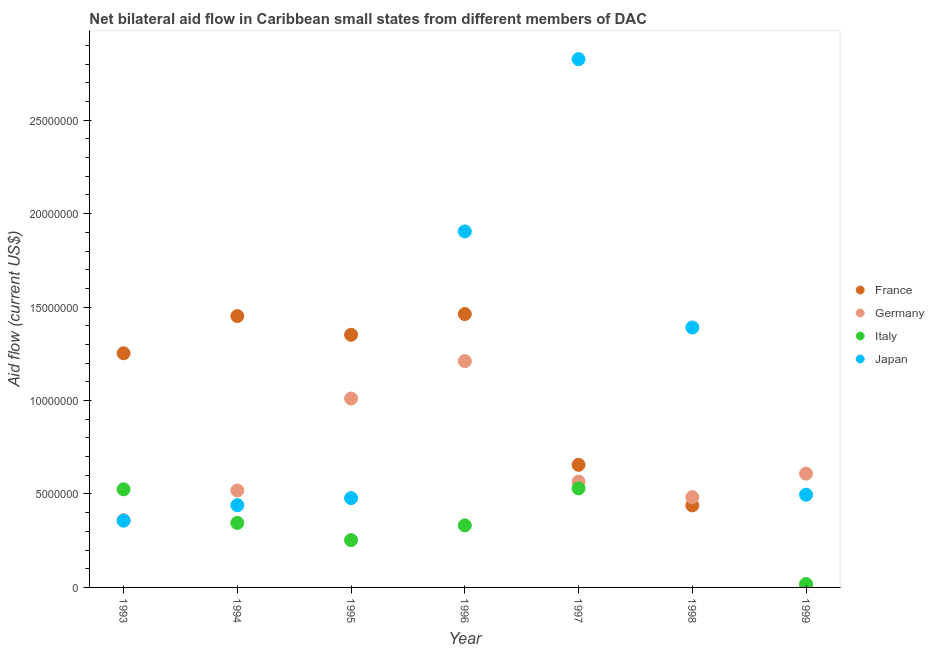What is the amount of aid given by italy in 1997?
Give a very brief answer. 5.30e+06. Across all years, what is the maximum amount of aid given by france?
Keep it short and to the point. 1.46e+07. Across all years, what is the minimum amount of aid given by france?
Offer a terse response. 10000. In which year was the amount of aid given by japan maximum?
Make the answer very short. 1997. What is the total amount of aid given by italy in the graph?
Keep it short and to the point. 2.00e+07. What is the difference between the amount of aid given by japan in 1998 and that in 1999?
Your answer should be compact. 8.95e+06. What is the difference between the amount of aid given by italy in 1993 and the amount of aid given by germany in 1995?
Make the answer very short. -4.86e+06. What is the average amount of aid given by italy per year?
Your answer should be very brief. 2.86e+06. In the year 1994, what is the difference between the amount of aid given by japan and amount of aid given by italy?
Offer a terse response. 9.50e+05. In how many years, is the amount of aid given by japan greater than 28000000 US$?
Offer a terse response. 1. What is the ratio of the amount of aid given by germany in 1994 to that in 1996?
Ensure brevity in your answer.  0.43. What is the difference between the highest and the second highest amount of aid given by france?
Your answer should be compact. 1.10e+05. What is the difference between the highest and the lowest amount of aid given by france?
Give a very brief answer. 1.46e+07. In how many years, is the amount of aid given by france greater than the average amount of aid given by france taken over all years?
Your answer should be very brief. 4. Is the sum of the amount of aid given by italy in 1993 and 1996 greater than the maximum amount of aid given by japan across all years?
Provide a short and direct response. No. Is it the case that in every year, the sum of the amount of aid given by france and amount of aid given by germany is greater than the amount of aid given by italy?
Offer a terse response. Yes. What is the difference between two consecutive major ticks on the Y-axis?
Offer a very short reply. 5.00e+06. Are the values on the major ticks of Y-axis written in scientific E-notation?
Offer a terse response. No. What is the title of the graph?
Offer a very short reply. Net bilateral aid flow in Caribbean small states from different members of DAC. What is the label or title of the Y-axis?
Give a very brief answer. Aid flow (current US$). What is the Aid flow (current US$) of France in 1993?
Your answer should be very brief. 1.25e+07. What is the Aid flow (current US$) in Germany in 1993?
Your answer should be compact. 3.60e+06. What is the Aid flow (current US$) of Italy in 1993?
Ensure brevity in your answer.  5.25e+06. What is the Aid flow (current US$) in Japan in 1993?
Ensure brevity in your answer.  3.57e+06. What is the Aid flow (current US$) of France in 1994?
Provide a short and direct response. 1.45e+07. What is the Aid flow (current US$) in Germany in 1994?
Offer a very short reply. 5.19e+06. What is the Aid flow (current US$) in Italy in 1994?
Make the answer very short. 3.45e+06. What is the Aid flow (current US$) of Japan in 1994?
Make the answer very short. 4.40e+06. What is the Aid flow (current US$) in France in 1995?
Your answer should be very brief. 1.35e+07. What is the Aid flow (current US$) in Germany in 1995?
Give a very brief answer. 1.01e+07. What is the Aid flow (current US$) of Italy in 1995?
Ensure brevity in your answer.  2.53e+06. What is the Aid flow (current US$) in Japan in 1995?
Offer a very short reply. 4.78e+06. What is the Aid flow (current US$) of France in 1996?
Offer a very short reply. 1.46e+07. What is the Aid flow (current US$) of Germany in 1996?
Make the answer very short. 1.21e+07. What is the Aid flow (current US$) of Italy in 1996?
Ensure brevity in your answer.  3.32e+06. What is the Aid flow (current US$) of Japan in 1996?
Ensure brevity in your answer.  1.90e+07. What is the Aid flow (current US$) of France in 1997?
Keep it short and to the point. 6.56e+06. What is the Aid flow (current US$) in Germany in 1997?
Your answer should be compact. 5.66e+06. What is the Aid flow (current US$) of Italy in 1997?
Your answer should be very brief. 5.30e+06. What is the Aid flow (current US$) of Japan in 1997?
Provide a succinct answer. 2.83e+07. What is the Aid flow (current US$) in France in 1998?
Provide a short and direct response. 4.39e+06. What is the Aid flow (current US$) in Germany in 1998?
Provide a short and direct response. 4.83e+06. What is the Aid flow (current US$) of Japan in 1998?
Your answer should be very brief. 1.39e+07. What is the Aid flow (current US$) in France in 1999?
Provide a short and direct response. 10000. What is the Aid flow (current US$) in Germany in 1999?
Give a very brief answer. 6.09e+06. What is the Aid flow (current US$) of Japan in 1999?
Give a very brief answer. 4.96e+06. Across all years, what is the maximum Aid flow (current US$) in France?
Offer a very short reply. 1.46e+07. Across all years, what is the maximum Aid flow (current US$) of Germany?
Your answer should be very brief. 1.21e+07. Across all years, what is the maximum Aid flow (current US$) of Italy?
Offer a terse response. 5.30e+06. Across all years, what is the maximum Aid flow (current US$) in Japan?
Provide a short and direct response. 2.83e+07. Across all years, what is the minimum Aid flow (current US$) of France?
Offer a very short reply. 10000. Across all years, what is the minimum Aid flow (current US$) of Germany?
Give a very brief answer. 3.60e+06. Across all years, what is the minimum Aid flow (current US$) of Italy?
Offer a very short reply. 0. Across all years, what is the minimum Aid flow (current US$) of Japan?
Make the answer very short. 3.57e+06. What is the total Aid flow (current US$) in France in the graph?
Your answer should be compact. 6.62e+07. What is the total Aid flow (current US$) in Germany in the graph?
Provide a short and direct response. 4.76e+07. What is the total Aid flow (current US$) in Italy in the graph?
Ensure brevity in your answer.  2.00e+07. What is the total Aid flow (current US$) of Japan in the graph?
Give a very brief answer. 7.89e+07. What is the difference between the Aid flow (current US$) in France in 1993 and that in 1994?
Give a very brief answer. -1.99e+06. What is the difference between the Aid flow (current US$) in Germany in 1993 and that in 1994?
Provide a short and direct response. -1.59e+06. What is the difference between the Aid flow (current US$) in Italy in 1993 and that in 1994?
Make the answer very short. 1.80e+06. What is the difference between the Aid flow (current US$) of Japan in 1993 and that in 1994?
Keep it short and to the point. -8.30e+05. What is the difference between the Aid flow (current US$) of France in 1993 and that in 1995?
Offer a terse response. -9.90e+05. What is the difference between the Aid flow (current US$) of Germany in 1993 and that in 1995?
Give a very brief answer. -6.51e+06. What is the difference between the Aid flow (current US$) in Italy in 1993 and that in 1995?
Ensure brevity in your answer.  2.72e+06. What is the difference between the Aid flow (current US$) in Japan in 1993 and that in 1995?
Your response must be concise. -1.21e+06. What is the difference between the Aid flow (current US$) of France in 1993 and that in 1996?
Your answer should be compact. -2.10e+06. What is the difference between the Aid flow (current US$) in Germany in 1993 and that in 1996?
Offer a very short reply. -8.51e+06. What is the difference between the Aid flow (current US$) in Italy in 1993 and that in 1996?
Your answer should be compact. 1.93e+06. What is the difference between the Aid flow (current US$) of Japan in 1993 and that in 1996?
Make the answer very short. -1.55e+07. What is the difference between the Aid flow (current US$) in France in 1993 and that in 1997?
Your answer should be compact. 5.97e+06. What is the difference between the Aid flow (current US$) of Germany in 1993 and that in 1997?
Your response must be concise. -2.06e+06. What is the difference between the Aid flow (current US$) of Japan in 1993 and that in 1997?
Ensure brevity in your answer.  -2.47e+07. What is the difference between the Aid flow (current US$) in France in 1993 and that in 1998?
Keep it short and to the point. 8.14e+06. What is the difference between the Aid flow (current US$) in Germany in 1993 and that in 1998?
Give a very brief answer. -1.23e+06. What is the difference between the Aid flow (current US$) of Japan in 1993 and that in 1998?
Make the answer very short. -1.03e+07. What is the difference between the Aid flow (current US$) in France in 1993 and that in 1999?
Your answer should be compact. 1.25e+07. What is the difference between the Aid flow (current US$) of Germany in 1993 and that in 1999?
Your response must be concise. -2.49e+06. What is the difference between the Aid flow (current US$) of Italy in 1993 and that in 1999?
Ensure brevity in your answer.  5.07e+06. What is the difference between the Aid flow (current US$) in Japan in 1993 and that in 1999?
Provide a succinct answer. -1.39e+06. What is the difference between the Aid flow (current US$) in France in 1994 and that in 1995?
Your answer should be compact. 1.00e+06. What is the difference between the Aid flow (current US$) in Germany in 1994 and that in 1995?
Make the answer very short. -4.92e+06. What is the difference between the Aid flow (current US$) in Italy in 1994 and that in 1995?
Give a very brief answer. 9.20e+05. What is the difference between the Aid flow (current US$) of Japan in 1994 and that in 1995?
Ensure brevity in your answer.  -3.80e+05. What is the difference between the Aid flow (current US$) in Germany in 1994 and that in 1996?
Keep it short and to the point. -6.92e+06. What is the difference between the Aid flow (current US$) in Japan in 1994 and that in 1996?
Keep it short and to the point. -1.46e+07. What is the difference between the Aid flow (current US$) in France in 1994 and that in 1997?
Your answer should be very brief. 7.96e+06. What is the difference between the Aid flow (current US$) in Germany in 1994 and that in 1997?
Your response must be concise. -4.70e+05. What is the difference between the Aid flow (current US$) of Italy in 1994 and that in 1997?
Your answer should be compact. -1.85e+06. What is the difference between the Aid flow (current US$) in Japan in 1994 and that in 1997?
Make the answer very short. -2.39e+07. What is the difference between the Aid flow (current US$) in France in 1994 and that in 1998?
Ensure brevity in your answer.  1.01e+07. What is the difference between the Aid flow (current US$) in Germany in 1994 and that in 1998?
Provide a short and direct response. 3.60e+05. What is the difference between the Aid flow (current US$) of Japan in 1994 and that in 1998?
Give a very brief answer. -9.51e+06. What is the difference between the Aid flow (current US$) of France in 1994 and that in 1999?
Provide a short and direct response. 1.45e+07. What is the difference between the Aid flow (current US$) in Germany in 1994 and that in 1999?
Keep it short and to the point. -9.00e+05. What is the difference between the Aid flow (current US$) in Italy in 1994 and that in 1999?
Your response must be concise. 3.27e+06. What is the difference between the Aid flow (current US$) in Japan in 1994 and that in 1999?
Provide a short and direct response. -5.60e+05. What is the difference between the Aid flow (current US$) of France in 1995 and that in 1996?
Ensure brevity in your answer.  -1.11e+06. What is the difference between the Aid flow (current US$) of Germany in 1995 and that in 1996?
Provide a succinct answer. -2.00e+06. What is the difference between the Aid flow (current US$) of Italy in 1995 and that in 1996?
Your answer should be very brief. -7.90e+05. What is the difference between the Aid flow (current US$) in Japan in 1995 and that in 1996?
Provide a short and direct response. -1.43e+07. What is the difference between the Aid flow (current US$) in France in 1995 and that in 1997?
Your answer should be compact. 6.96e+06. What is the difference between the Aid flow (current US$) in Germany in 1995 and that in 1997?
Make the answer very short. 4.45e+06. What is the difference between the Aid flow (current US$) of Italy in 1995 and that in 1997?
Make the answer very short. -2.77e+06. What is the difference between the Aid flow (current US$) of Japan in 1995 and that in 1997?
Ensure brevity in your answer.  -2.35e+07. What is the difference between the Aid flow (current US$) in France in 1995 and that in 1998?
Keep it short and to the point. 9.13e+06. What is the difference between the Aid flow (current US$) of Germany in 1995 and that in 1998?
Your answer should be very brief. 5.28e+06. What is the difference between the Aid flow (current US$) of Japan in 1995 and that in 1998?
Your answer should be very brief. -9.13e+06. What is the difference between the Aid flow (current US$) of France in 1995 and that in 1999?
Ensure brevity in your answer.  1.35e+07. What is the difference between the Aid flow (current US$) in Germany in 1995 and that in 1999?
Offer a very short reply. 4.02e+06. What is the difference between the Aid flow (current US$) in Italy in 1995 and that in 1999?
Provide a short and direct response. 2.35e+06. What is the difference between the Aid flow (current US$) in Japan in 1995 and that in 1999?
Offer a terse response. -1.80e+05. What is the difference between the Aid flow (current US$) in France in 1996 and that in 1997?
Provide a short and direct response. 8.07e+06. What is the difference between the Aid flow (current US$) of Germany in 1996 and that in 1997?
Provide a short and direct response. 6.45e+06. What is the difference between the Aid flow (current US$) in Italy in 1996 and that in 1997?
Offer a terse response. -1.98e+06. What is the difference between the Aid flow (current US$) in Japan in 1996 and that in 1997?
Provide a succinct answer. -9.22e+06. What is the difference between the Aid flow (current US$) of France in 1996 and that in 1998?
Your answer should be compact. 1.02e+07. What is the difference between the Aid flow (current US$) in Germany in 1996 and that in 1998?
Ensure brevity in your answer.  7.28e+06. What is the difference between the Aid flow (current US$) of Japan in 1996 and that in 1998?
Provide a short and direct response. 5.14e+06. What is the difference between the Aid flow (current US$) in France in 1996 and that in 1999?
Your answer should be compact. 1.46e+07. What is the difference between the Aid flow (current US$) in Germany in 1996 and that in 1999?
Give a very brief answer. 6.02e+06. What is the difference between the Aid flow (current US$) in Italy in 1996 and that in 1999?
Keep it short and to the point. 3.14e+06. What is the difference between the Aid flow (current US$) in Japan in 1996 and that in 1999?
Give a very brief answer. 1.41e+07. What is the difference between the Aid flow (current US$) in France in 1997 and that in 1998?
Give a very brief answer. 2.17e+06. What is the difference between the Aid flow (current US$) of Germany in 1997 and that in 1998?
Offer a terse response. 8.30e+05. What is the difference between the Aid flow (current US$) of Japan in 1997 and that in 1998?
Provide a succinct answer. 1.44e+07. What is the difference between the Aid flow (current US$) of France in 1997 and that in 1999?
Provide a succinct answer. 6.55e+06. What is the difference between the Aid flow (current US$) of Germany in 1997 and that in 1999?
Give a very brief answer. -4.30e+05. What is the difference between the Aid flow (current US$) of Italy in 1997 and that in 1999?
Make the answer very short. 5.12e+06. What is the difference between the Aid flow (current US$) of Japan in 1997 and that in 1999?
Keep it short and to the point. 2.33e+07. What is the difference between the Aid flow (current US$) of France in 1998 and that in 1999?
Your answer should be compact. 4.38e+06. What is the difference between the Aid flow (current US$) of Germany in 1998 and that in 1999?
Provide a succinct answer. -1.26e+06. What is the difference between the Aid flow (current US$) in Japan in 1998 and that in 1999?
Your answer should be very brief. 8.95e+06. What is the difference between the Aid flow (current US$) of France in 1993 and the Aid flow (current US$) of Germany in 1994?
Give a very brief answer. 7.34e+06. What is the difference between the Aid flow (current US$) in France in 1993 and the Aid flow (current US$) in Italy in 1994?
Offer a very short reply. 9.08e+06. What is the difference between the Aid flow (current US$) in France in 1993 and the Aid flow (current US$) in Japan in 1994?
Give a very brief answer. 8.13e+06. What is the difference between the Aid flow (current US$) of Germany in 1993 and the Aid flow (current US$) of Italy in 1994?
Your response must be concise. 1.50e+05. What is the difference between the Aid flow (current US$) in Germany in 1993 and the Aid flow (current US$) in Japan in 1994?
Offer a terse response. -8.00e+05. What is the difference between the Aid flow (current US$) of Italy in 1993 and the Aid flow (current US$) of Japan in 1994?
Make the answer very short. 8.50e+05. What is the difference between the Aid flow (current US$) in France in 1993 and the Aid flow (current US$) in Germany in 1995?
Your answer should be very brief. 2.42e+06. What is the difference between the Aid flow (current US$) of France in 1993 and the Aid flow (current US$) of Italy in 1995?
Your response must be concise. 1.00e+07. What is the difference between the Aid flow (current US$) of France in 1993 and the Aid flow (current US$) of Japan in 1995?
Your answer should be very brief. 7.75e+06. What is the difference between the Aid flow (current US$) in Germany in 1993 and the Aid flow (current US$) in Italy in 1995?
Ensure brevity in your answer.  1.07e+06. What is the difference between the Aid flow (current US$) of Germany in 1993 and the Aid flow (current US$) of Japan in 1995?
Your answer should be compact. -1.18e+06. What is the difference between the Aid flow (current US$) in France in 1993 and the Aid flow (current US$) in Italy in 1996?
Provide a short and direct response. 9.21e+06. What is the difference between the Aid flow (current US$) in France in 1993 and the Aid flow (current US$) in Japan in 1996?
Ensure brevity in your answer.  -6.52e+06. What is the difference between the Aid flow (current US$) of Germany in 1993 and the Aid flow (current US$) of Japan in 1996?
Your response must be concise. -1.54e+07. What is the difference between the Aid flow (current US$) of Italy in 1993 and the Aid flow (current US$) of Japan in 1996?
Make the answer very short. -1.38e+07. What is the difference between the Aid flow (current US$) of France in 1993 and the Aid flow (current US$) of Germany in 1997?
Make the answer very short. 6.87e+06. What is the difference between the Aid flow (current US$) of France in 1993 and the Aid flow (current US$) of Italy in 1997?
Provide a succinct answer. 7.23e+06. What is the difference between the Aid flow (current US$) of France in 1993 and the Aid flow (current US$) of Japan in 1997?
Provide a succinct answer. -1.57e+07. What is the difference between the Aid flow (current US$) of Germany in 1993 and the Aid flow (current US$) of Italy in 1997?
Give a very brief answer. -1.70e+06. What is the difference between the Aid flow (current US$) in Germany in 1993 and the Aid flow (current US$) in Japan in 1997?
Offer a terse response. -2.47e+07. What is the difference between the Aid flow (current US$) of Italy in 1993 and the Aid flow (current US$) of Japan in 1997?
Keep it short and to the point. -2.30e+07. What is the difference between the Aid flow (current US$) in France in 1993 and the Aid flow (current US$) in Germany in 1998?
Make the answer very short. 7.70e+06. What is the difference between the Aid flow (current US$) in France in 1993 and the Aid flow (current US$) in Japan in 1998?
Provide a succinct answer. -1.38e+06. What is the difference between the Aid flow (current US$) in Germany in 1993 and the Aid flow (current US$) in Japan in 1998?
Your response must be concise. -1.03e+07. What is the difference between the Aid flow (current US$) of Italy in 1993 and the Aid flow (current US$) of Japan in 1998?
Your answer should be compact. -8.66e+06. What is the difference between the Aid flow (current US$) of France in 1993 and the Aid flow (current US$) of Germany in 1999?
Your response must be concise. 6.44e+06. What is the difference between the Aid flow (current US$) in France in 1993 and the Aid flow (current US$) in Italy in 1999?
Your answer should be very brief. 1.24e+07. What is the difference between the Aid flow (current US$) in France in 1993 and the Aid flow (current US$) in Japan in 1999?
Make the answer very short. 7.57e+06. What is the difference between the Aid flow (current US$) in Germany in 1993 and the Aid flow (current US$) in Italy in 1999?
Offer a terse response. 3.42e+06. What is the difference between the Aid flow (current US$) of Germany in 1993 and the Aid flow (current US$) of Japan in 1999?
Offer a very short reply. -1.36e+06. What is the difference between the Aid flow (current US$) in France in 1994 and the Aid flow (current US$) in Germany in 1995?
Your answer should be compact. 4.41e+06. What is the difference between the Aid flow (current US$) of France in 1994 and the Aid flow (current US$) of Italy in 1995?
Your answer should be very brief. 1.20e+07. What is the difference between the Aid flow (current US$) of France in 1994 and the Aid flow (current US$) of Japan in 1995?
Your answer should be compact. 9.74e+06. What is the difference between the Aid flow (current US$) of Germany in 1994 and the Aid flow (current US$) of Italy in 1995?
Provide a short and direct response. 2.66e+06. What is the difference between the Aid flow (current US$) of Germany in 1994 and the Aid flow (current US$) of Japan in 1995?
Your answer should be very brief. 4.10e+05. What is the difference between the Aid flow (current US$) in Italy in 1994 and the Aid flow (current US$) in Japan in 1995?
Make the answer very short. -1.33e+06. What is the difference between the Aid flow (current US$) of France in 1994 and the Aid flow (current US$) of Germany in 1996?
Keep it short and to the point. 2.41e+06. What is the difference between the Aid flow (current US$) in France in 1994 and the Aid flow (current US$) in Italy in 1996?
Your answer should be very brief. 1.12e+07. What is the difference between the Aid flow (current US$) in France in 1994 and the Aid flow (current US$) in Japan in 1996?
Give a very brief answer. -4.53e+06. What is the difference between the Aid flow (current US$) of Germany in 1994 and the Aid flow (current US$) of Italy in 1996?
Ensure brevity in your answer.  1.87e+06. What is the difference between the Aid flow (current US$) of Germany in 1994 and the Aid flow (current US$) of Japan in 1996?
Keep it short and to the point. -1.39e+07. What is the difference between the Aid flow (current US$) in Italy in 1994 and the Aid flow (current US$) in Japan in 1996?
Provide a succinct answer. -1.56e+07. What is the difference between the Aid flow (current US$) in France in 1994 and the Aid flow (current US$) in Germany in 1997?
Provide a short and direct response. 8.86e+06. What is the difference between the Aid flow (current US$) of France in 1994 and the Aid flow (current US$) of Italy in 1997?
Your answer should be very brief. 9.22e+06. What is the difference between the Aid flow (current US$) in France in 1994 and the Aid flow (current US$) in Japan in 1997?
Keep it short and to the point. -1.38e+07. What is the difference between the Aid flow (current US$) of Germany in 1994 and the Aid flow (current US$) of Italy in 1997?
Make the answer very short. -1.10e+05. What is the difference between the Aid flow (current US$) of Germany in 1994 and the Aid flow (current US$) of Japan in 1997?
Offer a very short reply. -2.31e+07. What is the difference between the Aid flow (current US$) in Italy in 1994 and the Aid flow (current US$) in Japan in 1997?
Provide a short and direct response. -2.48e+07. What is the difference between the Aid flow (current US$) in France in 1994 and the Aid flow (current US$) in Germany in 1998?
Your answer should be very brief. 9.69e+06. What is the difference between the Aid flow (current US$) of Germany in 1994 and the Aid flow (current US$) of Japan in 1998?
Offer a terse response. -8.72e+06. What is the difference between the Aid flow (current US$) of Italy in 1994 and the Aid flow (current US$) of Japan in 1998?
Make the answer very short. -1.05e+07. What is the difference between the Aid flow (current US$) in France in 1994 and the Aid flow (current US$) in Germany in 1999?
Make the answer very short. 8.43e+06. What is the difference between the Aid flow (current US$) of France in 1994 and the Aid flow (current US$) of Italy in 1999?
Your answer should be very brief. 1.43e+07. What is the difference between the Aid flow (current US$) of France in 1994 and the Aid flow (current US$) of Japan in 1999?
Your answer should be compact. 9.56e+06. What is the difference between the Aid flow (current US$) in Germany in 1994 and the Aid flow (current US$) in Italy in 1999?
Your response must be concise. 5.01e+06. What is the difference between the Aid flow (current US$) of Germany in 1994 and the Aid flow (current US$) of Japan in 1999?
Your response must be concise. 2.30e+05. What is the difference between the Aid flow (current US$) in Italy in 1994 and the Aid flow (current US$) in Japan in 1999?
Keep it short and to the point. -1.51e+06. What is the difference between the Aid flow (current US$) of France in 1995 and the Aid flow (current US$) of Germany in 1996?
Give a very brief answer. 1.41e+06. What is the difference between the Aid flow (current US$) in France in 1995 and the Aid flow (current US$) in Italy in 1996?
Your answer should be very brief. 1.02e+07. What is the difference between the Aid flow (current US$) in France in 1995 and the Aid flow (current US$) in Japan in 1996?
Provide a short and direct response. -5.53e+06. What is the difference between the Aid flow (current US$) in Germany in 1995 and the Aid flow (current US$) in Italy in 1996?
Provide a succinct answer. 6.79e+06. What is the difference between the Aid flow (current US$) of Germany in 1995 and the Aid flow (current US$) of Japan in 1996?
Make the answer very short. -8.94e+06. What is the difference between the Aid flow (current US$) in Italy in 1995 and the Aid flow (current US$) in Japan in 1996?
Offer a very short reply. -1.65e+07. What is the difference between the Aid flow (current US$) of France in 1995 and the Aid flow (current US$) of Germany in 1997?
Offer a terse response. 7.86e+06. What is the difference between the Aid flow (current US$) of France in 1995 and the Aid flow (current US$) of Italy in 1997?
Make the answer very short. 8.22e+06. What is the difference between the Aid flow (current US$) in France in 1995 and the Aid flow (current US$) in Japan in 1997?
Give a very brief answer. -1.48e+07. What is the difference between the Aid flow (current US$) in Germany in 1995 and the Aid flow (current US$) in Italy in 1997?
Offer a very short reply. 4.81e+06. What is the difference between the Aid flow (current US$) of Germany in 1995 and the Aid flow (current US$) of Japan in 1997?
Your answer should be compact. -1.82e+07. What is the difference between the Aid flow (current US$) in Italy in 1995 and the Aid flow (current US$) in Japan in 1997?
Give a very brief answer. -2.57e+07. What is the difference between the Aid flow (current US$) in France in 1995 and the Aid flow (current US$) in Germany in 1998?
Give a very brief answer. 8.69e+06. What is the difference between the Aid flow (current US$) in France in 1995 and the Aid flow (current US$) in Japan in 1998?
Your answer should be very brief. -3.90e+05. What is the difference between the Aid flow (current US$) in Germany in 1995 and the Aid flow (current US$) in Japan in 1998?
Provide a short and direct response. -3.80e+06. What is the difference between the Aid flow (current US$) in Italy in 1995 and the Aid flow (current US$) in Japan in 1998?
Your response must be concise. -1.14e+07. What is the difference between the Aid flow (current US$) of France in 1995 and the Aid flow (current US$) of Germany in 1999?
Your answer should be compact. 7.43e+06. What is the difference between the Aid flow (current US$) of France in 1995 and the Aid flow (current US$) of Italy in 1999?
Your response must be concise. 1.33e+07. What is the difference between the Aid flow (current US$) of France in 1995 and the Aid flow (current US$) of Japan in 1999?
Give a very brief answer. 8.56e+06. What is the difference between the Aid flow (current US$) in Germany in 1995 and the Aid flow (current US$) in Italy in 1999?
Give a very brief answer. 9.93e+06. What is the difference between the Aid flow (current US$) of Germany in 1995 and the Aid flow (current US$) of Japan in 1999?
Ensure brevity in your answer.  5.15e+06. What is the difference between the Aid flow (current US$) of Italy in 1995 and the Aid flow (current US$) of Japan in 1999?
Keep it short and to the point. -2.43e+06. What is the difference between the Aid flow (current US$) in France in 1996 and the Aid flow (current US$) in Germany in 1997?
Make the answer very short. 8.97e+06. What is the difference between the Aid flow (current US$) in France in 1996 and the Aid flow (current US$) in Italy in 1997?
Provide a succinct answer. 9.33e+06. What is the difference between the Aid flow (current US$) of France in 1996 and the Aid flow (current US$) of Japan in 1997?
Ensure brevity in your answer.  -1.36e+07. What is the difference between the Aid flow (current US$) in Germany in 1996 and the Aid flow (current US$) in Italy in 1997?
Offer a terse response. 6.81e+06. What is the difference between the Aid flow (current US$) in Germany in 1996 and the Aid flow (current US$) in Japan in 1997?
Keep it short and to the point. -1.62e+07. What is the difference between the Aid flow (current US$) of Italy in 1996 and the Aid flow (current US$) of Japan in 1997?
Ensure brevity in your answer.  -2.50e+07. What is the difference between the Aid flow (current US$) in France in 1996 and the Aid flow (current US$) in Germany in 1998?
Your answer should be compact. 9.80e+06. What is the difference between the Aid flow (current US$) of France in 1996 and the Aid flow (current US$) of Japan in 1998?
Your answer should be very brief. 7.20e+05. What is the difference between the Aid flow (current US$) of Germany in 1996 and the Aid flow (current US$) of Japan in 1998?
Your answer should be very brief. -1.80e+06. What is the difference between the Aid flow (current US$) of Italy in 1996 and the Aid flow (current US$) of Japan in 1998?
Give a very brief answer. -1.06e+07. What is the difference between the Aid flow (current US$) in France in 1996 and the Aid flow (current US$) in Germany in 1999?
Your response must be concise. 8.54e+06. What is the difference between the Aid flow (current US$) of France in 1996 and the Aid flow (current US$) of Italy in 1999?
Your answer should be compact. 1.44e+07. What is the difference between the Aid flow (current US$) in France in 1996 and the Aid flow (current US$) in Japan in 1999?
Offer a very short reply. 9.67e+06. What is the difference between the Aid flow (current US$) of Germany in 1996 and the Aid flow (current US$) of Italy in 1999?
Your answer should be compact. 1.19e+07. What is the difference between the Aid flow (current US$) of Germany in 1996 and the Aid flow (current US$) of Japan in 1999?
Make the answer very short. 7.15e+06. What is the difference between the Aid flow (current US$) in Italy in 1996 and the Aid flow (current US$) in Japan in 1999?
Ensure brevity in your answer.  -1.64e+06. What is the difference between the Aid flow (current US$) in France in 1997 and the Aid flow (current US$) in Germany in 1998?
Your answer should be very brief. 1.73e+06. What is the difference between the Aid flow (current US$) in France in 1997 and the Aid flow (current US$) in Japan in 1998?
Make the answer very short. -7.35e+06. What is the difference between the Aid flow (current US$) in Germany in 1997 and the Aid flow (current US$) in Japan in 1998?
Your answer should be compact. -8.25e+06. What is the difference between the Aid flow (current US$) of Italy in 1997 and the Aid flow (current US$) of Japan in 1998?
Make the answer very short. -8.61e+06. What is the difference between the Aid flow (current US$) of France in 1997 and the Aid flow (current US$) of Italy in 1999?
Your answer should be compact. 6.38e+06. What is the difference between the Aid flow (current US$) in France in 1997 and the Aid flow (current US$) in Japan in 1999?
Make the answer very short. 1.60e+06. What is the difference between the Aid flow (current US$) in Germany in 1997 and the Aid flow (current US$) in Italy in 1999?
Offer a very short reply. 5.48e+06. What is the difference between the Aid flow (current US$) of Germany in 1997 and the Aid flow (current US$) of Japan in 1999?
Offer a very short reply. 7.00e+05. What is the difference between the Aid flow (current US$) in Italy in 1997 and the Aid flow (current US$) in Japan in 1999?
Keep it short and to the point. 3.40e+05. What is the difference between the Aid flow (current US$) of France in 1998 and the Aid flow (current US$) of Germany in 1999?
Your answer should be compact. -1.70e+06. What is the difference between the Aid flow (current US$) of France in 1998 and the Aid flow (current US$) of Italy in 1999?
Your answer should be very brief. 4.21e+06. What is the difference between the Aid flow (current US$) in France in 1998 and the Aid flow (current US$) in Japan in 1999?
Provide a succinct answer. -5.70e+05. What is the difference between the Aid flow (current US$) of Germany in 1998 and the Aid flow (current US$) of Italy in 1999?
Ensure brevity in your answer.  4.65e+06. What is the difference between the Aid flow (current US$) of Germany in 1998 and the Aid flow (current US$) of Japan in 1999?
Your answer should be very brief. -1.30e+05. What is the average Aid flow (current US$) in France per year?
Your answer should be compact. 9.45e+06. What is the average Aid flow (current US$) in Germany per year?
Keep it short and to the point. 6.80e+06. What is the average Aid flow (current US$) in Italy per year?
Provide a succinct answer. 2.86e+06. What is the average Aid flow (current US$) in Japan per year?
Make the answer very short. 1.13e+07. In the year 1993, what is the difference between the Aid flow (current US$) of France and Aid flow (current US$) of Germany?
Your answer should be compact. 8.93e+06. In the year 1993, what is the difference between the Aid flow (current US$) of France and Aid flow (current US$) of Italy?
Keep it short and to the point. 7.28e+06. In the year 1993, what is the difference between the Aid flow (current US$) of France and Aid flow (current US$) of Japan?
Provide a succinct answer. 8.96e+06. In the year 1993, what is the difference between the Aid flow (current US$) of Germany and Aid flow (current US$) of Italy?
Make the answer very short. -1.65e+06. In the year 1993, what is the difference between the Aid flow (current US$) in Italy and Aid flow (current US$) in Japan?
Offer a very short reply. 1.68e+06. In the year 1994, what is the difference between the Aid flow (current US$) in France and Aid flow (current US$) in Germany?
Your response must be concise. 9.33e+06. In the year 1994, what is the difference between the Aid flow (current US$) of France and Aid flow (current US$) of Italy?
Your response must be concise. 1.11e+07. In the year 1994, what is the difference between the Aid flow (current US$) in France and Aid flow (current US$) in Japan?
Keep it short and to the point. 1.01e+07. In the year 1994, what is the difference between the Aid flow (current US$) in Germany and Aid flow (current US$) in Italy?
Your answer should be compact. 1.74e+06. In the year 1994, what is the difference between the Aid flow (current US$) of Germany and Aid flow (current US$) of Japan?
Your answer should be very brief. 7.90e+05. In the year 1994, what is the difference between the Aid flow (current US$) in Italy and Aid flow (current US$) in Japan?
Offer a very short reply. -9.50e+05. In the year 1995, what is the difference between the Aid flow (current US$) of France and Aid flow (current US$) of Germany?
Your response must be concise. 3.41e+06. In the year 1995, what is the difference between the Aid flow (current US$) in France and Aid flow (current US$) in Italy?
Offer a terse response. 1.10e+07. In the year 1995, what is the difference between the Aid flow (current US$) in France and Aid flow (current US$) in Japan?
Make the answer very short. 8.74e+06. In the year 1995, what is the difference between the Aid flow (current US$) in Germany and Aid flow (current US$) in Italy?
Offer a very short reply. 7.58e+06. In the year 1995, what is the difference between the Aid flow (current US$) of Germany and Aid flow (current US$) of Japan?
Offer a very short reply. 5.33e+06. In the year 1995, what is the difference between the Aid flow (current US$) in Italy and Aid flow (current US$) in Japan?
Provide a succinct answer. -2.25e+06. In the year 1996, what is the difference between the Aid flow (current US$) of France and Aid flow (current US$) of Germany?
Your answer should be compact. 2.52e+06. In the year 1996, what is the difference between the Aid flow (current US$) in France and Aid flow (current US$) in Italy?
Provide a short and direct response. 1.13e+07. In the year 1996, what is the difference between the Aid flow (current US$) of France and Aid flow (current US$) of Japan?
Ensure brevity in your answer.  -4.42e+06. In the year 1996, what is the difference between the Aid flow (current US$) in Germany and Aid flow (current US$) in Italy?
Your answer should be compact. 8.79e+06. In the year 1996, what is the difference between the Aid flow (current US$) of Germany and Aid flow (current US$) of Japan?
Offer a very short reply. -6.94e+06. In the year 1996, what is the difference between the Aid flow (current US$) in Italy and Aid flow (current US$) in Japan?
Make the answer very short. -1.57e+07. In the year 1997, what is the difference between the Aid flow (current US$) in France and Aid flow (current US$) in Germany?
Ensure brevity in your answer.  9.00e+05. In the year 1997, what is the difference between the Aid flow (current US$) in France and Aid flow (current US$) in Italy?
Give a very brief answer. 1.26e+06. In the year 1997, what is the difference between the Aid flow (current US$) of France and Aid flow (current US$) of Japan?
Offer a very short reply. -2.17e+07. In the year 1997, what is the difference between the Aid flow (current US$) in Germany and Aid flow (current US$) in Italy?
Your answer should be very brief. 3.60e+05. In the year 1997, what is the difference between the Aid flow (current US$) in Germany and Aid flow (current US$) in Japan?
Your answer should be very brief. -2.26e+07. In the year 1997, what is the difference between the Aid flow (current US$) in Italy and Aid flow (current US$) in Japan?
Give a very brief answer. -2.30e+07. In the year 1998, what is the difference between the Aid flow (current US$) in France and Aid flow (current US$) in Germany?
Your response must be concise. -4.40e+05. In the year 1998, what is the difference between the Aid flow (current US$) in France and Aid flow (current US$) in Japan?
Your answer should be very brief. -9.52e+06. In the year 1998, what is the difference between the Aid flow (current US$) of Germany and Aid flow (current US$) of Japan?
Your answer should be very brief. -9.08e+06. In the year 1999, what is the difference between the Aid flow (current US$) in France and Aid flow (current US$) in Germany?
Your response must be concise. -6.08e+06. In the year 1999, what is the difference between the Aid flow (current US$) of France and Aid flow (current US$) of Italy?
Make the answer very short. -1.70e+05. In the year 1999, what is the difference between the Aid flow (current US$) in France and Aid flow (current US$) in Japan?
Give a very brief answer. -4.95e+06. In the year 1999, what is the difference between the Aid flow (current US$) of Germany and Aid flow (current US$) of Italy?
Your response must be concise. 5.91e+06. In the year 1999, what is the difference between the Aid flow (current US$) in Germany and Aid flow (current US$) in Japan?
Keep it short and to the point. 1.13e+06. In the year 1999, what is the difference between the Aid flow (current US$) in Italy and Aid flow (current US$) in Japan?
Your answer should be compact. -4.78e+06. What is the ratio of the Aid flow (current US$) in France in 1993 to that in 1994?
Your answer should be compact. 0.86. What is the ratio of the Aid flow (current US$) of Germany in 1993 to that in 1994?
Make the answer very short. 0.69. What is the ratio of the Aid flow (current US$) of Italy in 1993 to that in 1994?
Keep it short and to the point. 1.52. What is the ratio of the Aid flow (current US$) of Japan in 1993 to that in 1994?
Give a very brief answer. 0.81. What is the ratio of the Aid flow (current US$) of France in 1993 to that in 1995?
Offer a very short reply. 0.93. What is the ratio of the Aid flow (current US$) of Germany in 1993 to that in 1995?
Provide a short and direct response. 0.36. What is the ratio of the Aid flow (current US$) of Italy in 1993 to that in 1995?
Your answer should be very brief. 2.08. What is the ratio of the Aid flow (current US$) of Japan in 1993 to that in 1995?
Offer a very short reply. 0.75. What is the ratio of the Aid flow (current US$) in France in 1993 to that in 1996?
Your answer should be very brief. 0.86. What is the ratio of the Aid flow (current US$) of Germany in 1993 to that in 1996?
Make the answer very short. 0.3. What is the ratio of the Aid flow (current US$) of Italy in 1993 to that in 1996?
Provide a short and direct response. 1.58. What is the ratio of the Aid flow (current US$) of Japan in 1993 to that in 1996?
Offer a very short reply. 0.19. What is the ratio of the Aid flow (current US$) in France in 1993 to that in 1997?
Offer a very short reply. 1.91. What is the ratio of the Aid flow (current US$) in Germany in 1993 to that in 1997?
Provide a short and direct response. 0.64. What is the ratio of the Aid flow (current US$) of Italy in 1993 to that in 1997?
Keep it short and to the point. 0.99. What is the ratio of the Aid flow (current US$) of Japan in 1993 to that in 1997?
Your response must be concise. 0.13. What is the ratio of the Aid flow (current US$) of France in 1993 to that in 1998?
Your response must be concise. 2.85. What is the ratio of the Aid flow (current US$) of Germany in 1993 to that in 1998?
Ensure brevity in your answer.  0.75. What is the ratio of the Aid flow (current US$) of Japan in 1993 to that in 1998?
Offer a very short reply. 0.26. What is the ratio of the Aid flow (current US$) of France in 1993 to that in 1999?
Your response must be concise. 1253. What is the ratio of the Aid flow (current US$) in Germany in 1993 to that in 1999?
Give a very brief answer. 0.59. What is the ratio of the Aid flow (current US$) of Italy in 1993 to that in 1999?
Keep it short and to the point. 29.17. What is the ratio of the Aid flow (current US$) in Japan in 1993 to that in 1999?
Your response must be concise. 0.72. What is the ratio of the Aid flow (current US$) in France in 1994 to that in 1995?
Provide a succinct answer. 1.07. What is the ratio of the Aid flow (current US$) in Germany in 1994 to that in 1995?
Your response must be concise. 0.51. What is the ratio of the Aid flow (current US$) in Italy in 1994 to that in 1995?
Your answer should be compact. 1.36. What is the ratio of the Aid flow (current US$) in Japan in 1994 to that in 1995?
Give a very brief answer. 0.92. What is the ratio of the Aid flow (current US$) of Germany in 1994 to that in 1996?
Keep it short and to the point. 0.43. What is the ratio of the Aid flow (current US$) in Italy in 1994 to that in 1996?
Provide a short and direct response. 1.04. What is the ratio of the Aid flow (current US$) of Japan in 1994 to that in 1996?
Make the answer very short. 0.23. What is the ratio of the Aid flow (current US$) in France in 1994 to that in 1997?
Provide a short and direct response. 2.21. What is the ratio of the Aid flow (current US$) in Germany in 1994 to that in 1997?
Offer a very short reply. 0.92. What is the ratio of the Aid flow (current US$) in Italy in 1994 to that in 1997?
Your answer should be very brief. 0.65. What is the ratio of the Aid flow (current US$) in Japan in 1994 to that in 1997?
Your response must be concise. 0.16. What is the ratio of the Aid flow (current US$) of France in 1994 to that in 1998?
Offer a very short reply. 3.31. What is the ratio of the Aid flow (current US$) in Germany in 1994 to that in 1998?
Your response must be concise. 1.07. What is the ratio of the Aid flow (current US$) of Japan in 1994 to that in 1998?
Make the answer very short. 0.32. What is the ratio of the Aid flow (current US$) in France in 1994 to that in 1999?
Provide a short and direct response. 1452. What is the ratio of the Aid flow (current US$) in Germany in 1994 to that in 1999?
Offer a very short reply. 0.85. What is the ratio of the Aid flow (current US$) in Italy in 1994 to that in 1999?
Offer a terse response. 19.17. What is the ratio of the Aid flow (current US$) in Japan in 1994 to that in 1999?
Give a very brief answer. 0.89. What is the ratio of the Aid flow (current US$) in France in 1995 to that in 1996?
Ensure brevity in your answer.  0.92. What is the ratio of the Aid flow (current US$) of Germany in 1995 to that in 1996?
Provide a short and direct response. 0.83. What is the ratio of the Aid flow (current US$) in Italy in 1995 to that in 1996?
Your answer should be compact. 0.76. What is the ratio of the Aid flow (current US$) in Japan in 1995 to that in 1996?
Provide a succinct answer. 0.25. What is the ratio of the Aid flow (current US$) of France in 1995 to that in 1997?
Make the answer very short. 2.06. What is the ratio of the Aid flow (current US$) of Germany in 1995 to that in 1997?
Your answer should be very brief. 1.79. What is the ratio of the Aid flow (current US$) of Italy in 1995 to that in 1997?
Keep it short and to the point. 0.48. What is the ratio of the Aid flow (current US$) of Japan in 1995 to that in 1997?
Make the answer very short. 0.17. What is the ratio of the Aid flow (current US$) of France in 1995 to that in 1998?
Provide a short and direct response. 3.08. What is the ratio of the Aid flow (current US$) of Germany in 1995 to that in 1998?
Give a very brief answer. 2.09. What is the ratio of the Aid flow (current US$) of Japan in 1995 to that in 1998?
Provide a succinct answer. 0.34. What is the ratio of the Aid flow (current US$) of France in 1995 to that in 1999?
Your answer should be compact. 1352. What is the ratio of the Aid flow (current US$) of Germany in 1995 to that in 1999?
Offer a terse response. 1.66. What is the ratio of the Aid flow (current US$) of Italy in 1995 to that in 1999?
Offer a very short reply. 14.06. What is the ratio of the Aid flow (current US$) of Japan in 1995 to that in 1999?
Your answer should be compact. 0.96. What is the ratio of the Aid flow (current US$) of France in 1996 to that in 1997?
Provide a short and direct response. 2.23. What is the ratio of the Aid flow (current US$) of Germany in 1996 to that in 1997?
Keep it short and to the point. 2.14. What is the ratio of the Aid flow (current US$) in Italy in 1996 to that in 1997?
Provide a short and direct response. 0.63. What is the ratio of the Aid flow (current US$) in Japan in 1996 to that in 1997?
Offer a terse response. 0.67. What is the ratio of the Aid flow (current US$) of France in 1996 to that in 1998?
Offer a very short reply. 3.33. What is the ratio of the Aid flow (current US$) in Germany in 1996 to that in 1998?
Give a very brief answer. 2.51. What is the ratio of the Aid flow (current US$) in Japan in 1996 to that in 1998?
Offer a terse response. 1.37. What is the ratio of the Aid flow (current US$) in France in 1996 to that in 1999?
Your answer should be very brief. 1463. What is the ratio of the Aid flow (current US$) of Germany in 1996 to that in 1999?
Offer a very short reply. 1.99. What is the ratio of the Aid flow (current US$) in Italy in 1996 to that in 1999?
Your answer should be very brief. 18.44. What is the ratio of the Aid flow (current US$) in Japan in 1996 to that in 1999?
Provide a succinct answer. 3.84. What is the ratio of the Aid flow (current US$) of France in 1997 to that in 1998?
Give a very brief answer. 1.49. What is the ratio of the Aid flow (current US$) in Germany in 1997 to that in 1998?
Make the answer very short. 1.17. What is the ratio of the Aid flow (current US$) of Japan in 1997 to that in 1998?
Provide a succinct answer. 2.03. What is the ratio of the Aid flow (current US$) of France in 1997 to that in 1999?
Your response must be concise. 656. What is the ratio of the Aid flow (current US$) of Germany in 1997 to that in 1999?
Your response must be concise. 0.93. What is the ratio of the Aid flow (current US$) in Italy in 1997 to that in 1999?
Provide a succinct answer. 29.44. What is the ratio of the Aid flow (current US$) in Japan in 1997 to that in 1999?
Offer a very short reply. 5.7. What is the ratio of the Aid flow (current US$) in France in 1998 to that in 1999?
Provide a succinct answer. 439. What is the ratio of the Aid flow (current US$) in Germany in 1998 to that in 1999?
Your answer should be compact. 0.79. What is the ratio of the Aid flow (current US$) in Japan in 1998 to that in 1999?
Ensure brevity in your answer.  2.8. What is the difference between the highest and the second highest Aid flow (current US$) in France?
Ensure brevity in your answer.  1.10e+05. What is the difference between the highest and the second highest Aid flow (current US$) in Germany?
Your answer should be compact. 2.00e+06. What is the difference between the highest and the second highest Aid flow (current US$) of Italy?
Provide a succinct answer. 5.00e+04. What is the difference between the highest and the second highest Aid flow (current US$) in Japan?
Provide a short and direct response. 9.22e+06. What is the difference between the highest and the lowest Aid flow (current US$) of France?
Your answer should be very brief. 1.46e+07. What is the difference between the highest and the lowest Aid flow (current US$) in Germany?
Your answer should be compact. 8.51e+06. What is the difference between the highest and the lowest Aid flow (current US$) of Italy?
Give a very brief answer. 5.30e+06. What is the difference between the highest and the lowest Aid flow (current US$) of Japan?
Your answer should be compact. 2.47e+07. 